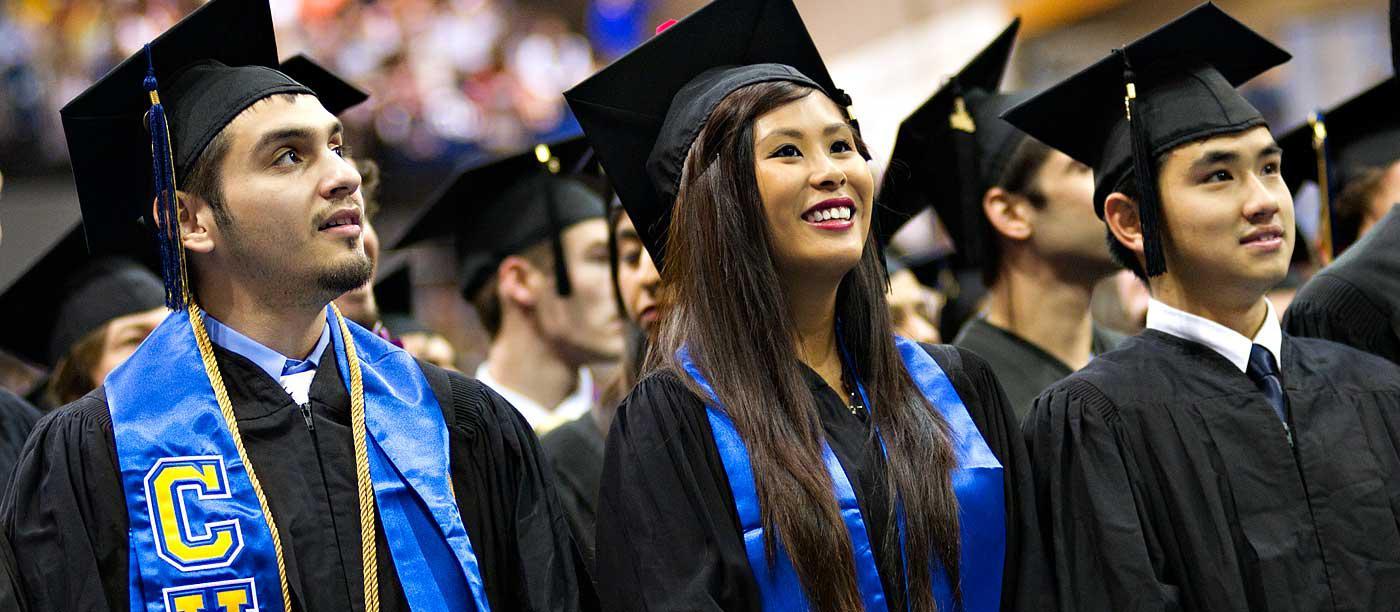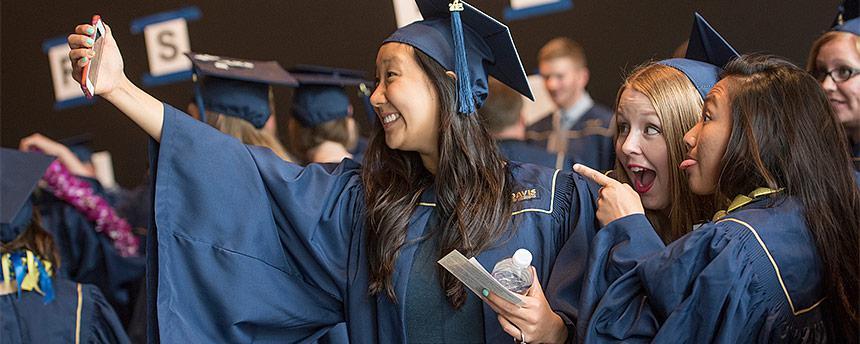The first image is the image on the left, the second image is the image on the right. For the images shown, is this caption "In the image to the right, the graduation gown is blue." true? Answer yes or no. Yes. 